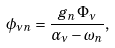Convert formula to latex. <formula><loc_0><loc_0><loc_500><loc_500>\phi _ { \nu n } = \frac { g _ { n } \Phi _ { \nu } } { \alpha _ { \nu } - \omega _ { n } } ,</formula> 